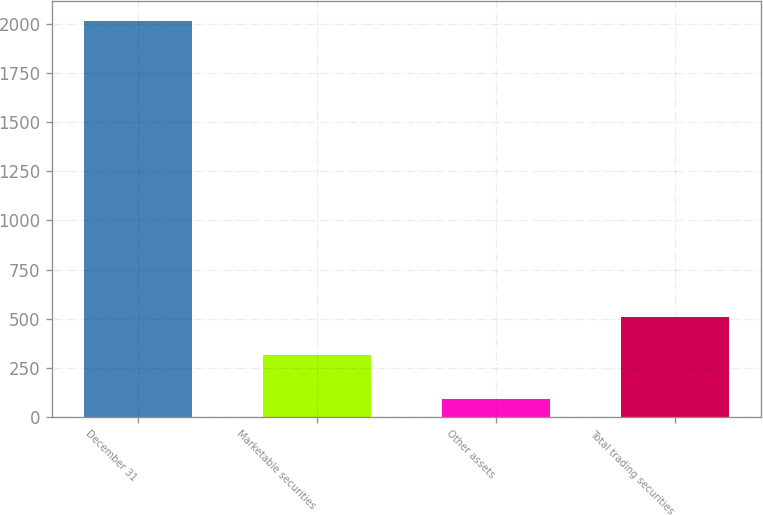Convert chart. <chart><loc_0><loc_0><loc_500><loc_500><bar_chart><fcel>December 31<fcel>Marketable securities<fcel>Other assets<fcel>Total trading securities<nl><fcel>2014<fcel>315<fcel>94<fcel>507<nl></chart> 